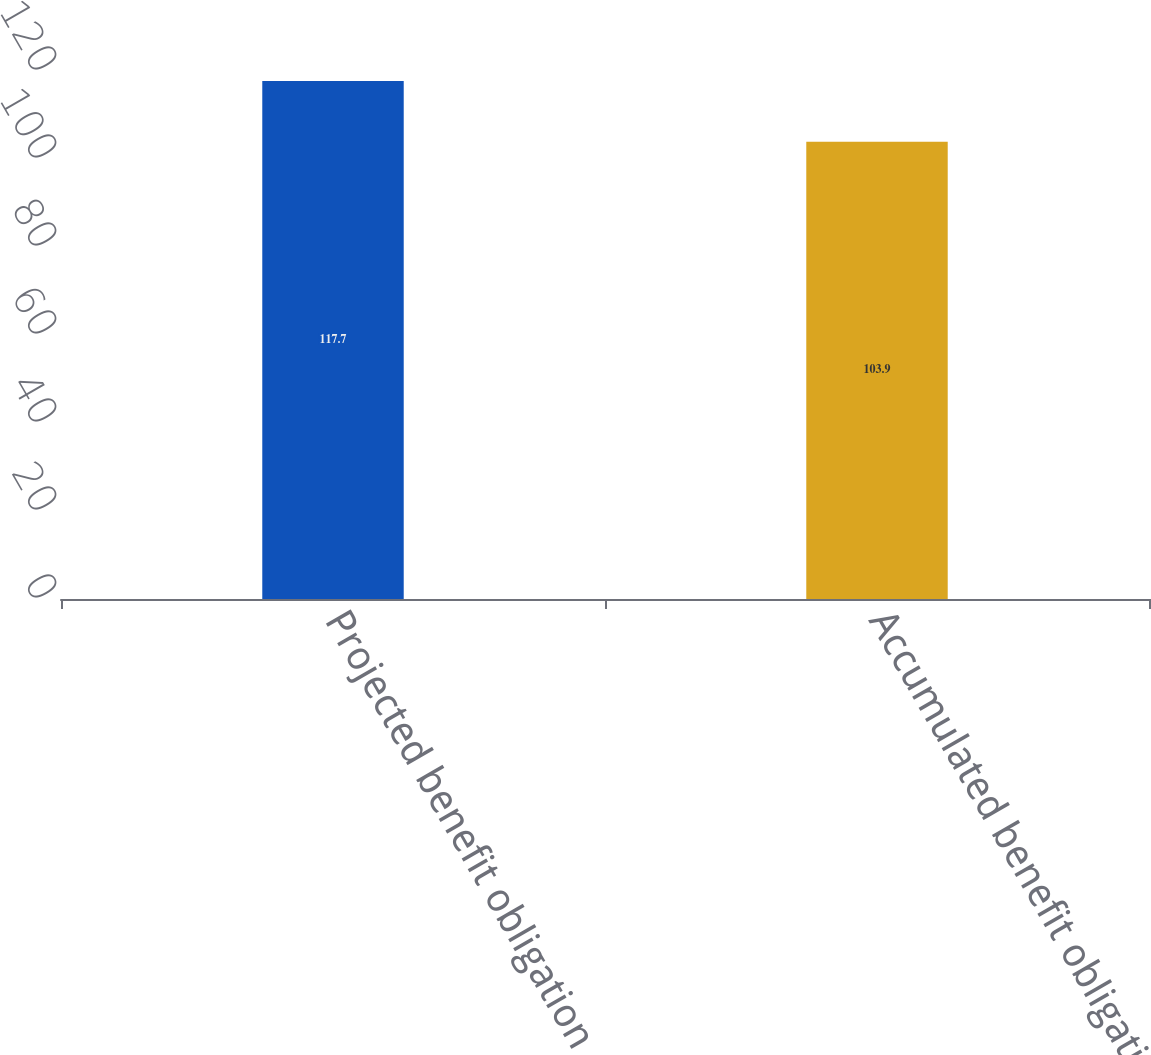Convert chart to OTSL. <chart><loc_0><loc_0><loc_500><loc_500><bar_chart><fcel>Projected benefit obligation<fcel>Accumulated benefit obligation<nl><fcel>117.7<fcel>103.9<nl></chart> 